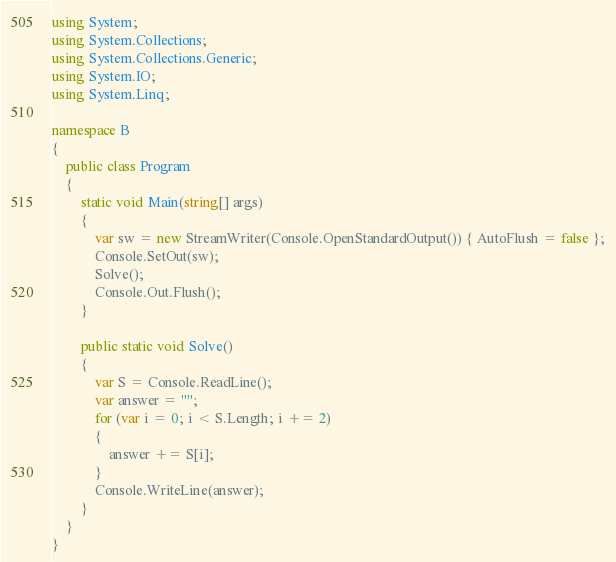<code> <loc_0><loc_0><loc_500><loc_500><_C#_>using System;
using System.Collections;
using System.Collections.Generic;
using System.IO;
using System.Linq;

namespace B
{
    public class Program
    {
        static void Main(string[] args)
        {
            var sw = new StreamWriter(Console.OpenStandardOutput()) { AutoFlush = false };
            Console.SetOut(sw);
            Solve();
            Console.Out.Flush();
        }

        public static void Solve()
        {
            var S = Console.ReadLine();
            var answer = "";
            for (var i = 0; i < S.Length; i += 2)
            {
                answer += S[i];
            }
            Console.WriteLine(answer);
        }
    }
}
</code> 